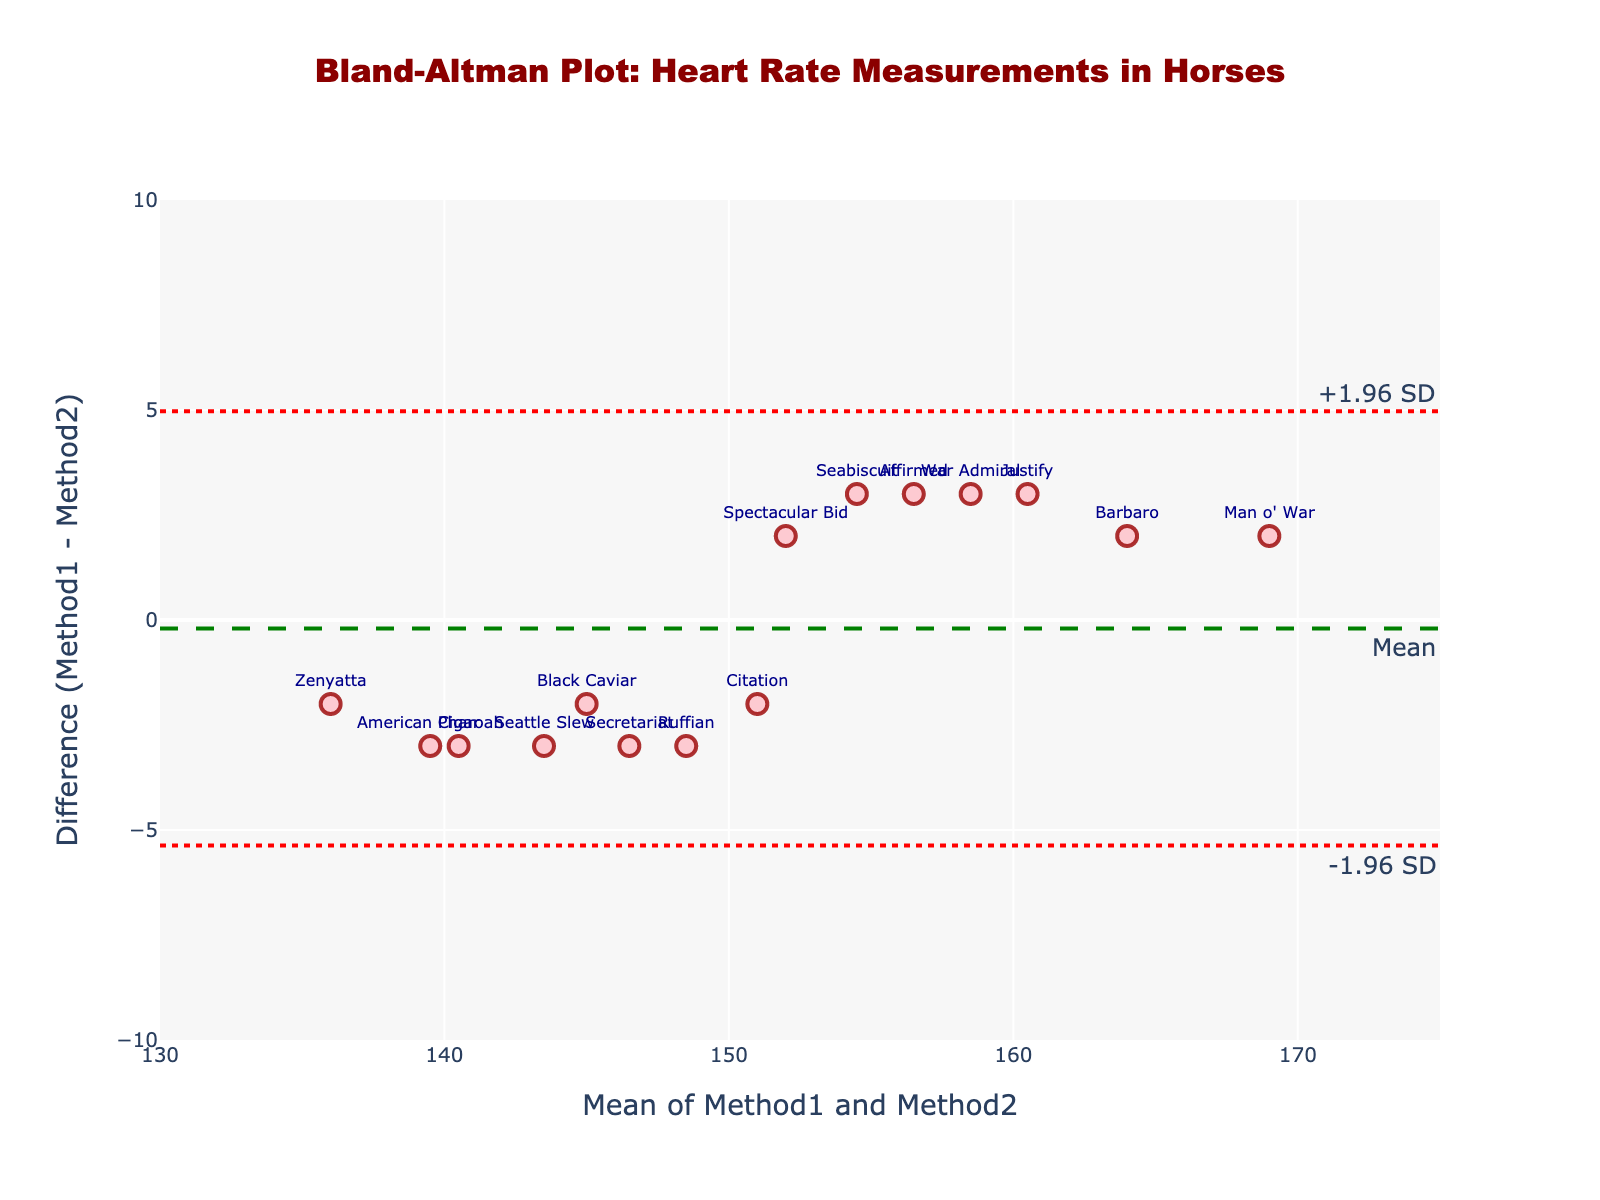What is the title of the plot? The title is usually located at the top of the plot and reads, "Bland-Altman Plot: Heart Rate Measurements in Horses." This title indicates the purpose of the plot, which is to compare the heart rate measurements between two methods for horses.
Answer: Bland-Altman Plot: Heart Rate Measurements in Horses How many horses are represented in the plot? Count the number of markers (data points) in the plot. Each represents one horse. According to the provided data and plot, there should be 15 horses.
Answer: 15 What is the range of the x-axis? Look at the x-axis to find the minimum and maximum values. According to the plot settings, the range spans from 130 to 175.
Answer: 130 to 175 What is the color of the data points in the plot? Observe the color of the markers. They are described as light pink with darker edges, which correlates to a light pinkish color.
Answer: Light pink What is the y-axis value of the line that represents the mean difference? The line indicating the mean difference is highlighted and labeled. It is the green dashed line at the datum, representing the mean difference of 0.
Answer: 0 What are the values of the upper and lower limits of agreement? These are found by identifying the red dotted lines. The upper limit is +1.96 SD and the lower limit is -1.96 SD. The values are around 2.53 and -2.53, respectively.
Answer: +2.53, -2.53 Which horse has the highest mean heart rate between the two methods? By observing the x-axis, locate the marker farthest to the right. This horse has the highest mean heart rate, identifiable by its label 'Man o' War.' Look at the x-value of this horse.
Answer: Man o' War Which horse shows the largest difference between the two methods? This is determined by looking at the y-axis for the marker furthest from the baseline. The highest positive difference is 'Secretariat', and the highest negative difference is 'Man o' War.' Choose the absolute highest difference.
Answer: Secretariat What is the average of Method 1 and Method 2 heart rate for the horse 'Justify'? Look for the marker labeled 'Justify' and find its x-axis position which represents the mean of Method 1 and Method 2 heart rate for this horse. The value should be around the middle of the x-axis range.
Answer: 160.5 Is there a trend in the differences as the mean heart rate increases? Evaluate if the markers on the plot form a pattern. A possible trend might be visible if differences increase or decrease as the mean heart rate increases, though our plot shows no clear trend. This indicates that the differences are scattered without a clear pattern related to the mean heart rate.
Answer: No clear trend 